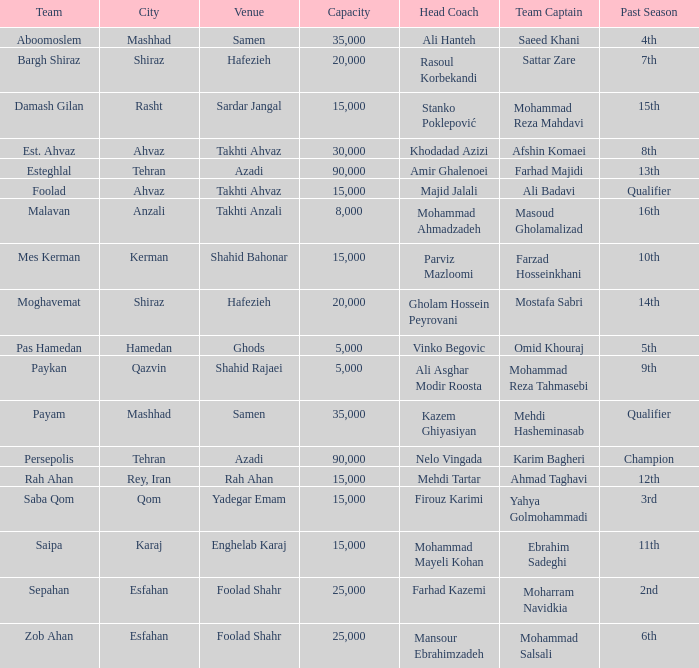What is the Capacity of the Venue of Head Coach Ali Asghar Modir Roosta? 5000.0. 